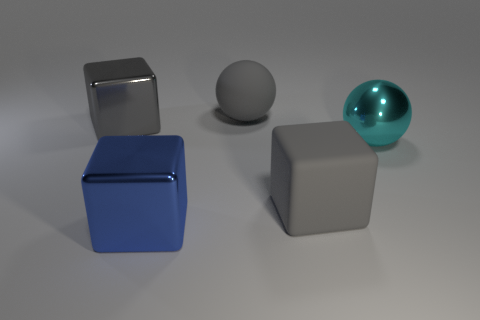Subtract all big gray cubes. How many cubes are left? 1 Subtract all yellow cylinders. How many gray blocks are left? 2 Subtract all blue blocks. How many blocks are left? 2 Subtract 1 cubes. How many cubes are left? 2 Add 5 tiny cyan rubber balls. How many objects exist? 10 Subtract all blocks. How many objects are left? 2 Add 1 big gray rubber objects. How many big gray rubber objects are left? 3 Add 5 cyan metal spheres. How many cyan metal spheres exist? 6 Subtract 0 green blocks. How many objects are left? 5 Subtract all red balls. Subtract all purple cubes. How many balls are left? 2 